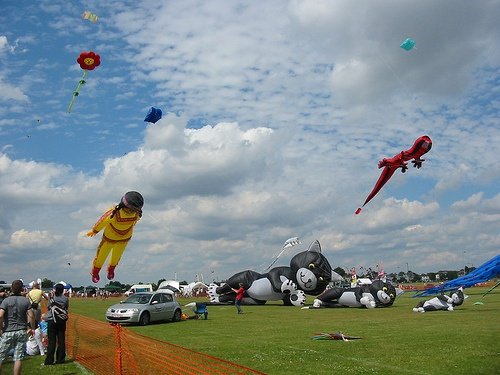Describe the objects in this image and their specific colors. I can see kite in blue, black, gray, darkgray, and lightgray tones, kite in blue, olive, maroon, black, and darkgray tones, car in blue, black, gray, darkgray, and lightgray tones, people in blue, black, gray, darkgray, and purple tones, and kite in blue, black, gray, darkgray, and lightgray tones in this image. 